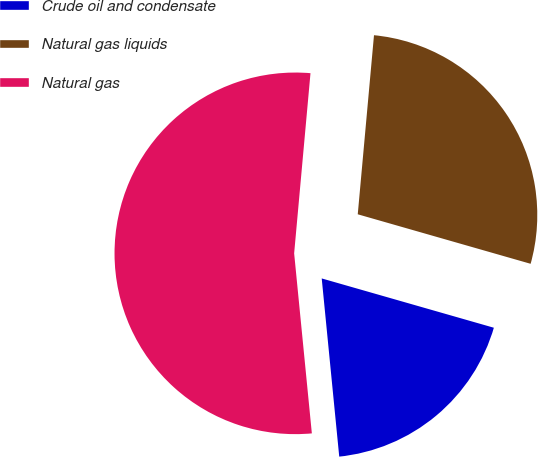<chart> <loc_0><loc_0><loc_500><loc_500><pie_chart><fcel>Crude oil and condensate<fcel>Natural gas liquids<fcel>Natural gas<nl><fcel>19.0%<fcel>28.0%<fcel>53.0%<nl></chart> 